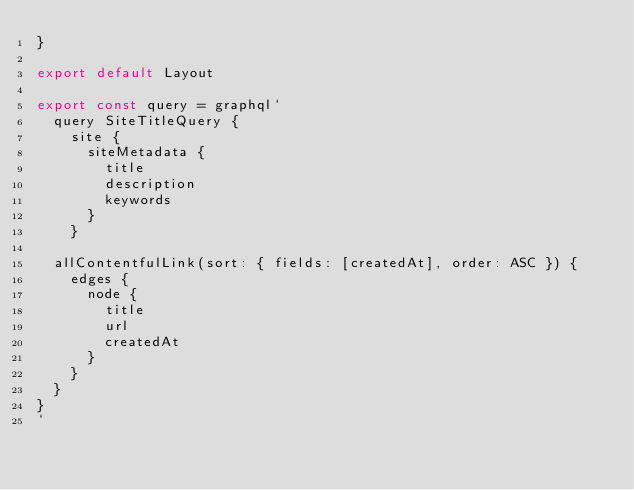<code> <loc_0><loc_0><loc_500><loc_500><_JavaScript_>}

export default Layout

export const query = graphql`
  query SiteTitleQuery {
    site {
      siteMetadata {
        title
        description
        keywords
      }
    }

  allContentfulLink(sort: { fields: [createdAt], order: ASC }) {
    edges {
      node {
        title
        url
        createdAt
      }
    }
  }
}
`
</code> 